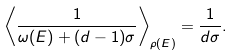<formula> <loc_0><loc_0><loc_500><loc_500>\left \langle \frac { 1 } { \omega ( E ) + ( d - 1 ) \sigma } \right \rangle _ { \rho ( E ) } = \frac { 1 } { d \sigma } .</formula> 